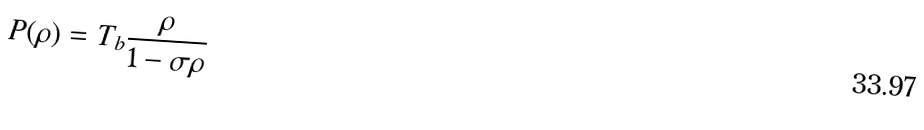Convert formula to latex. <formula><loc_0><loc_0><loc_500><loc_500>P ( \rho ) = T _ { b } \frac { \rho } { 1 - \sigma \rho }</formula> 